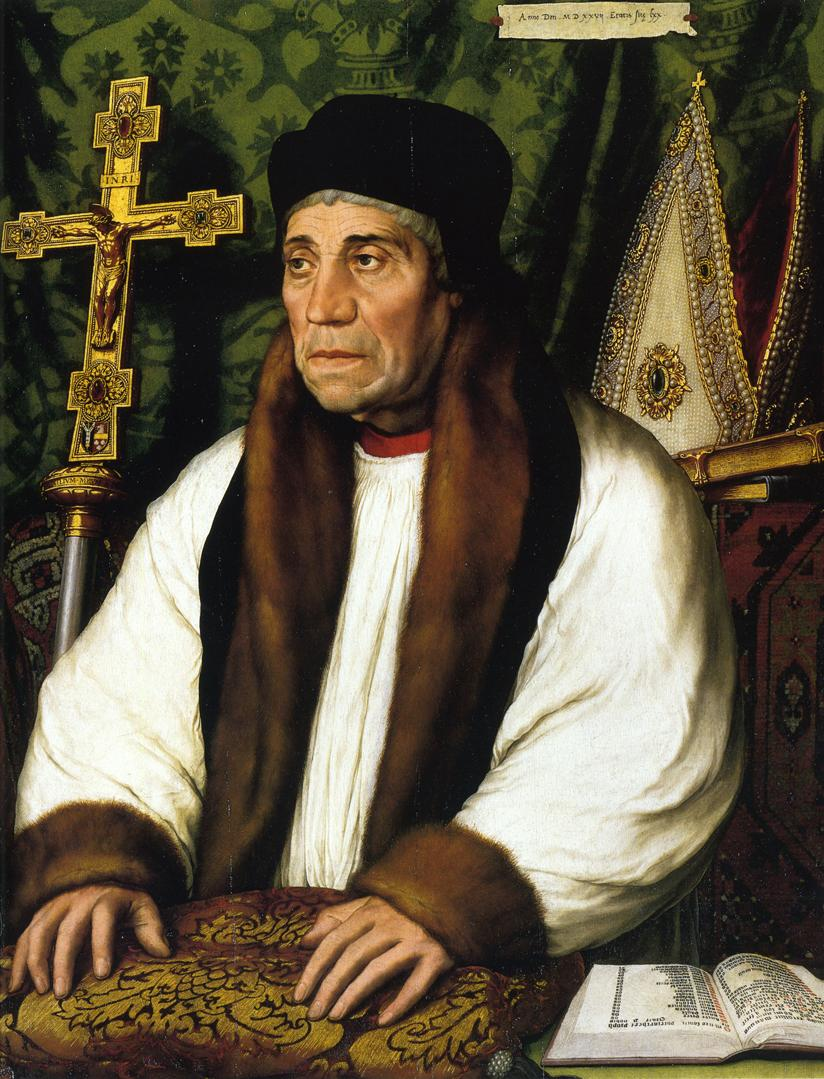Can you recognize the type of book the man is reading? While it is difficult to determine the exact type of book from the image, the presence of the large cross and the man's clerical attire suggest that it could be a religious text, possibly a Bible or a book of prayers. Why do you think the artist chose such a detailed background? The artist likely chose the detailed background to highlight the subject's status and environment. The rich green tapestry with gold patterns suggests wealth and importance, and it enhances the overall grandeur of the composition, emphasizing the man's significant position in a religious or scholarly context. 